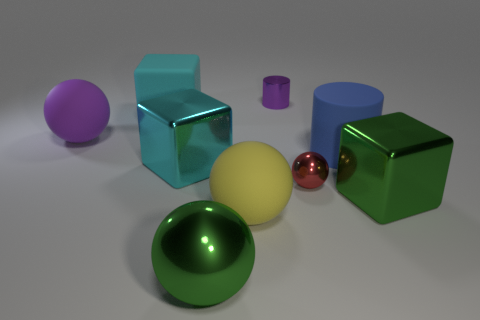How many objects are small things in front of the big purple rubber object or tiny metallic objects that are in front of the blue cylinder?
Offer a terse response. 1. There is a blue object; is it the same shape as the large metallic thing that is to the right of the tiny purple cylinder?
Your answer should be compact. No. How many other objects are there of the same shape as the big purple thing?
Ensure brevity in your answer.  3. What number of objects are either purple matte things or big yellow spheres?
Your answer should be compact. 2. Do the small cylinder and the small shiny ball have the same color?
Provide a short and direct response. No. Are there any other things that have the same size as the yellow thing?
Your response must be concise. Yes. What is the shape of the small shiny object that is to the right of the small metal object that is behind the large purple thing?
Your answer should be compact. Sphere. Are there fewer green shiny spheres than metallic balls?
Your answer should be compact. Yes. How big is the block that is both to the left of the green metallic sphere and right of the large matte block?
Make the answer very short. Large. Does the cyan metal thing have the same size as the cyan matte thing?
Offer a very short reply. Yes. 